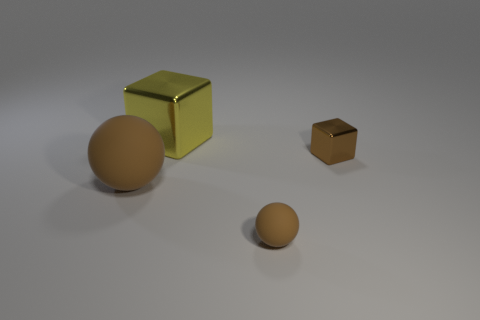Is the color of the small rubber ball the same as the big metal object?
Provide a short and direct response. No. How many big things are either brown shiny things or cyan matte spheres?
Provide a succinct answer. 0. What is the size of the other brown thing that is the same shape as the tiny rubber thing?
Give a very brief answer. Large. How many objects are both behind the big brown rubber ball and left of the tiny brown matte object?
Provide a short and direct response. 1. There is a large metal object; does it have the same shape as the small brown object that is behind the small sphere?
Offer a terse response. Yes. Are there more spheres that are to the right of the large yellow shiny thing than green things?
Give a very brief answer. Yes. Is the number of balls behind the yellow block less than the number of red rubber cylinders?
Ensure brevity in your answer.  No. What number of big blocks have the same color as the tiny metal block?
Keep it short and to the point. 0. The object that is both in front of the small brown shiny block and to the right of the yellow block is made of what material?
Provide a short and direct response. Rubber. There is a small thing behind the large brown thing; is its color the same as the big matte thing that is left of the large metal object?
Make the answer very short. Yes. 